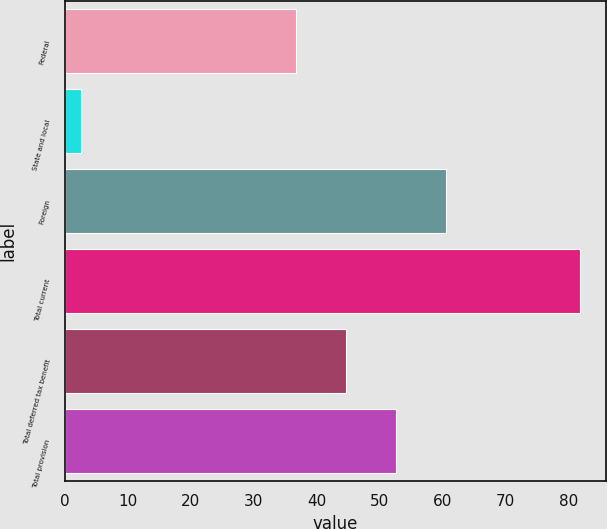Convert chart to OTSL. <chart><loc_0><loc_0><loc_500><loc_500><bar_chart><fcel>Federal<fcel>State and local<fcel>Foreign<fcel>Total current<fcel>Total deferred tax benefit<fcel>Total provision<nl><fcel>36.7<fcel>2.6<fcel>60.49<fcel>81.9<fcel>44.63<fcel>52.56<nl></chart> 